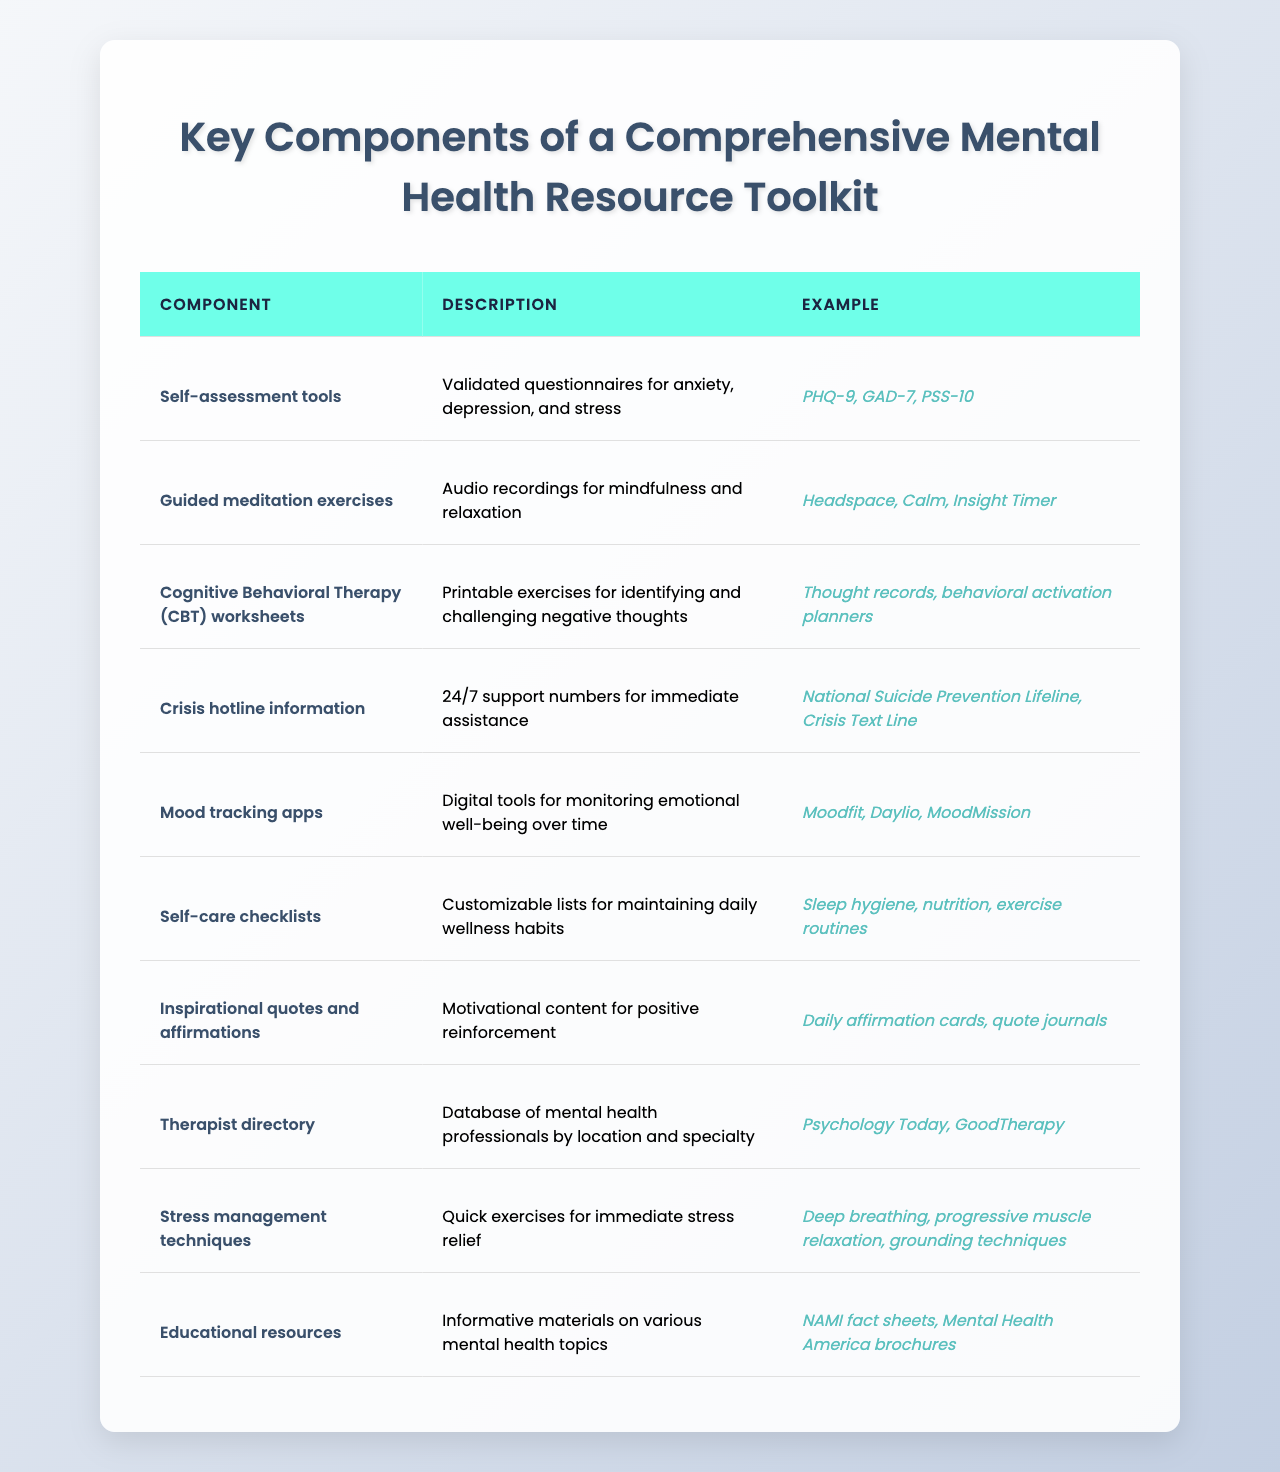What is one example of a self-assessment tool mentioned in the table? The table lists PHQ-9 as one example of a self-assessment tool under the "Self-assessment tools" component.
Answer: PHQ-9 How many components are mentioned in the toolkit? The table includes a total of 10 components, each detailing a different aspect of mental health resources.
Answer: 10 Which component provides information on immediate assistance? The "Crisis hotline information" component lists support numbers that provide immediate assistance for those in crisis.
Answer: Crisis hotline information Do guided meditation exercises include audio recordings? Yes, the description for "Guided meditation exercises" states they are audio recordings designed for mindfulness and relaxation.
Answer: Yes Which component includes tools for monitoring emotional well-being over time? The "Mood tracking apps" component focuses on digital tools for tracking emotional well-being consistently.
Answer: Mood tracking apps Is there a component that involves education on mental health topics? Yes, the table includes "Educational resources," which provides informative materials on various mental health subjects.
Answer: Yes What is the difference between crisis hotline information and therapist directory in the table? "Crisis hotline information" offers immediate support numbers, while the "Therapist directory" provides a database of mental health professionals by location and specialty.
Answer: Immediate support vs. directory of professionals How many different types of exercises for stress relief are listed? The "Stress management techniques" component mentions three types of exercises: deep breathing, progressive muscle relaxation, and grounding techniques.
Answer: 3 From which component can you find motivational content? The "Inspirational quotes and affirmations" component includes motivational content for positive reinforcement, such as daily affirmation cards or quote journals.
Answer: Inspirational quotes and affirmations What is the last component mentioned in the table? The last component is "Educational resources," which details informative materials on various mental health topics.
Answer: Educational resources 